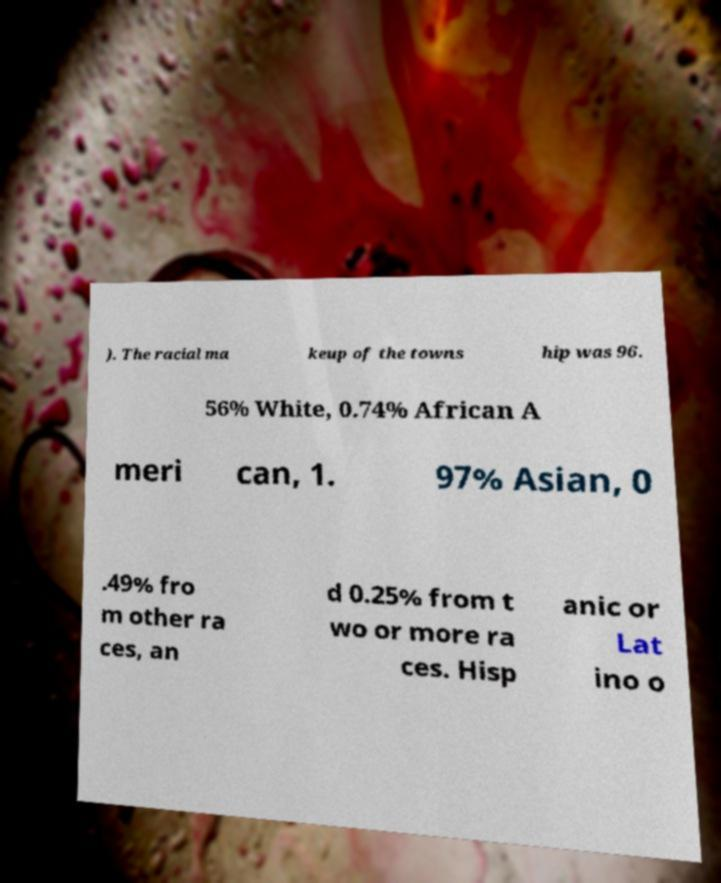Please read and relay the text visible in this image. What does it say? ). The racial ma keup of the towns hip was 96. 56% White, 0.74% African A meri can, 1. 97% Asian, 0 .49% fro m other ra ces, an d 0.25% from t wo or more ra ces. Hisp anic or Lat ino o 